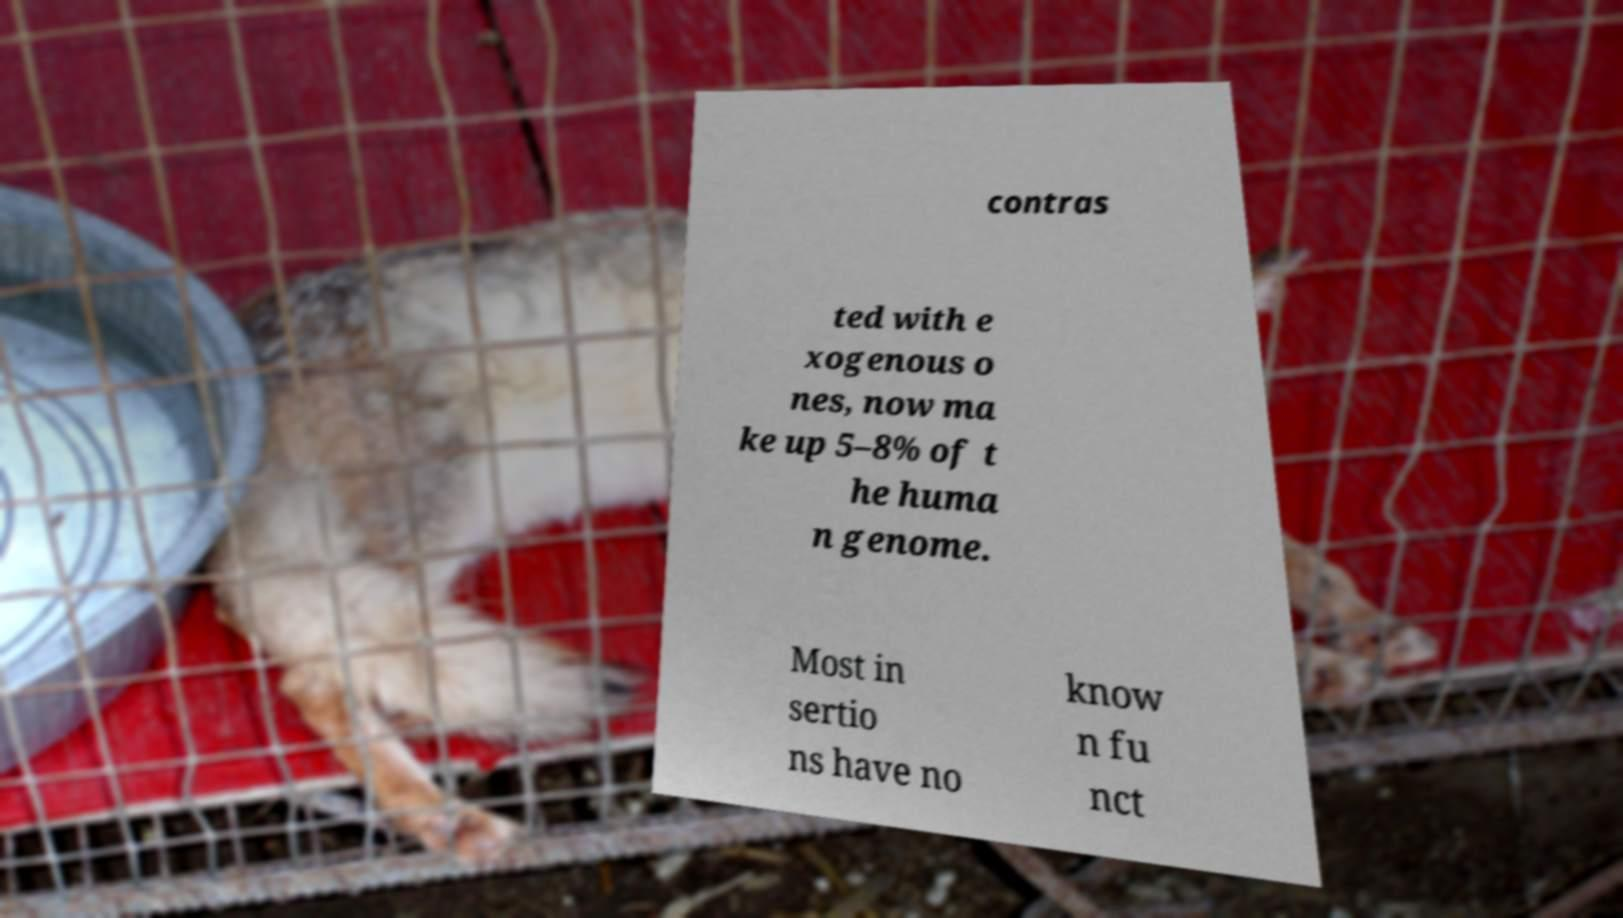Could you assist in decoding the text presented in this image and type it out clearly? contras ted with e xogenous o nes, now ma ke up 5–8% of t he huma n genome. Most in sertio ns have no know n fu nct 